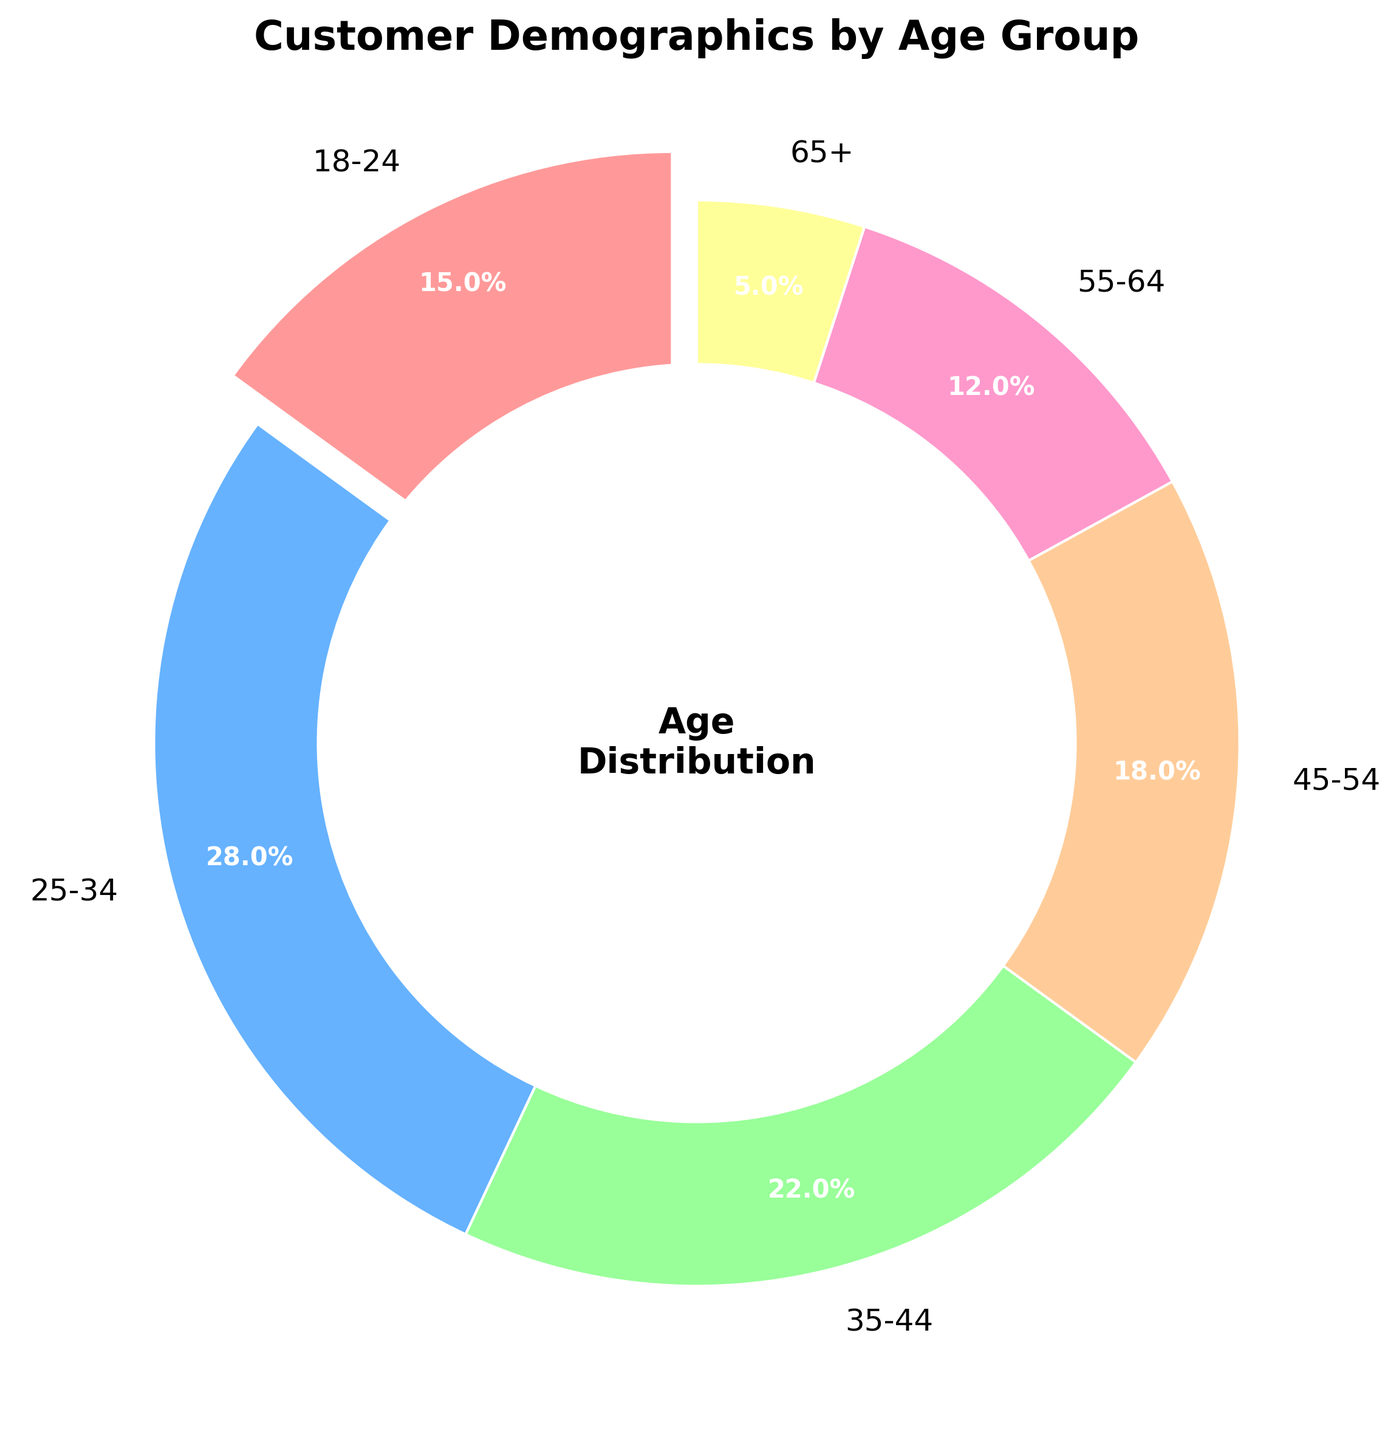What is the largest age group of customers? The pie chart shows the percentage of each age group. The largest segment is the one labeled 25-34 with 28%.
Answer: 25-34 Which age group has the smallest percentage of customers? According to the chart, the smallest slice represents the 65+ group, which is 5%.
Answer: 65+ Which two age groups together comprise more than half of the customers? We need to sum the percentages of different groups. 25-34 (28%) + 35-44 (22%) = 50%, which is exactly half. To exceed half, we need another combination. Sum 15% (18-24) + 28% (25-34) = 43%, that's not enough. The combination of 28% (25-34) + 22% (35-44) is the only one that makes sense here.
Answer: 25-34 and 35-44 How much larger is the 25-34 age group compared to the 55-64 age group? The percentage of 25-34 is 28%, and the percentage of 55-64 is 12%. The difference is 28% - 12% = 16%.
Answer: 16% What percentage of customers is under 35 years old? We add the percentages of the 18-24 (15%) and 25-34 (28%) age groups. 15% + 28% = 43%.
Answer: 43% Which color represents the 45-54 age group on the pie chart? By observing the pie chart, each color is assigned to an age group. The 45-54 group is represented by an orange color.
Answer: Orange If another survey of 1000 customers matched this distribution, how many customers would be 35-44 years old? If 22% of customers are in the 35-44 age group, for 1000 customers, we calculate 0.22 * 1000 = 220.
Answer: 220 Compare the customer distribution between age groups 35-44 and 55-64. Which is larger and by how much? The pie chart indicates 35-44 is 22% and 55-64 is 12%. The 35-44 group is larger by 22% - 12% = 10%.
Answer: 35-44 by 10% What proportion of customers are aged 45 and over? Add the percentages of the age groups 45-54 (18%), 55-64 (12%), and 65+ (5%). 18% + 12% + 5% = 35%.
Answer: 35% 